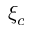Convert formula to latex. <formula><loc_0><loc_0><loc_500><loc_500>\xi _ { c }</formula> 